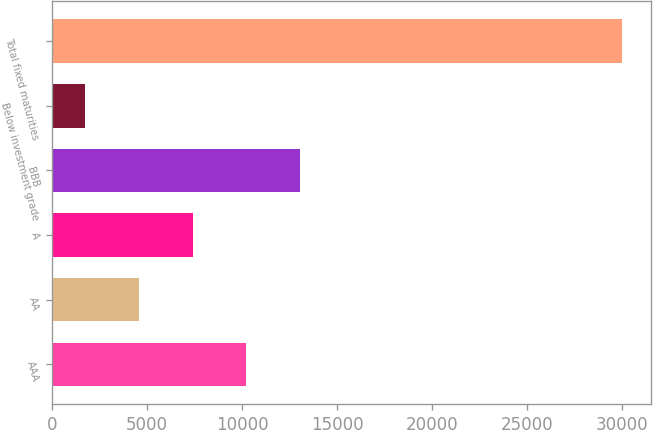Convert chart. <chart><loc_0><loc_0><loc_500><loc_500><bar_chart><fcel>AAA<fcel>AA<fcel>A<fcel>BBB<fcel>Below investment grade<fcel>Total fixed maturities<nl><fcel>10221.4<fcel>4567.8<fcel>7394.6<fcel>13048.2<fcel>1741<fcel>30009<nl></chart> 